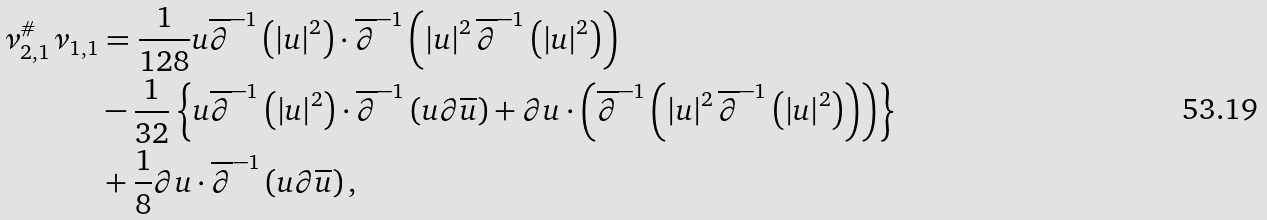<formula> <loc_0><loc_0><loc_500><loc_500>\nu _ { 2 , 1 } ^ { \# } \nu _ { 1 , 1 } & = \frac { 1 } { 1 2 8 } u \overline { \partial } ^ { - 1 } \left ( \left | u \right | ^ { 2 } \right ) \cdot \overline { \partial } ^ { - 1 } \left ( \left | u \right | ^ { 2 } \overline { \partial } ^ { - 1 } \left ( \left | u \right | ^ { 2 } \right ) \right ) \\ & - \frac { 1 } { 3 2 } \left \{ u \overline { \partial } ^ { - 1 } \left ( \left | u \right | ^ { 2 } \right ) \cdot \overline { \partial } ^ { - 1 } \left ( u \partial \overline { u } \right ) + \partial u \cdot \left ( \overline { \partial } ^ { - 1 } \left ( \left | u \right | ^ { 2 } \overline { \partial } ^ { - 1 } \left ( \left | u \right | ^ { 2 } \right ) \right ) \right ) \right \} \\ & + \frac { 1 } { 8 } \partial u \cdot \overline { \partial } ^ { - 1 } \left ( u \partial \overline { u } \right ) ,</formula> 